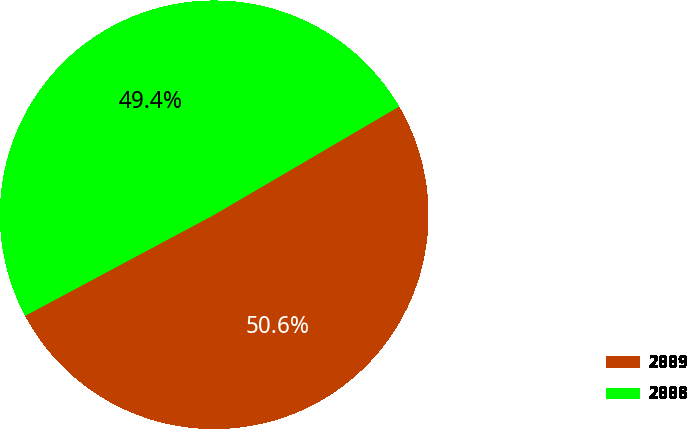Convert chart. <chart><loc_0><loc_0><loc_500><loc_500><pie_chart><fcel>2009<fcel>2008<nl><fcel>50.62%<fcel>49.38%<nl></chart> 